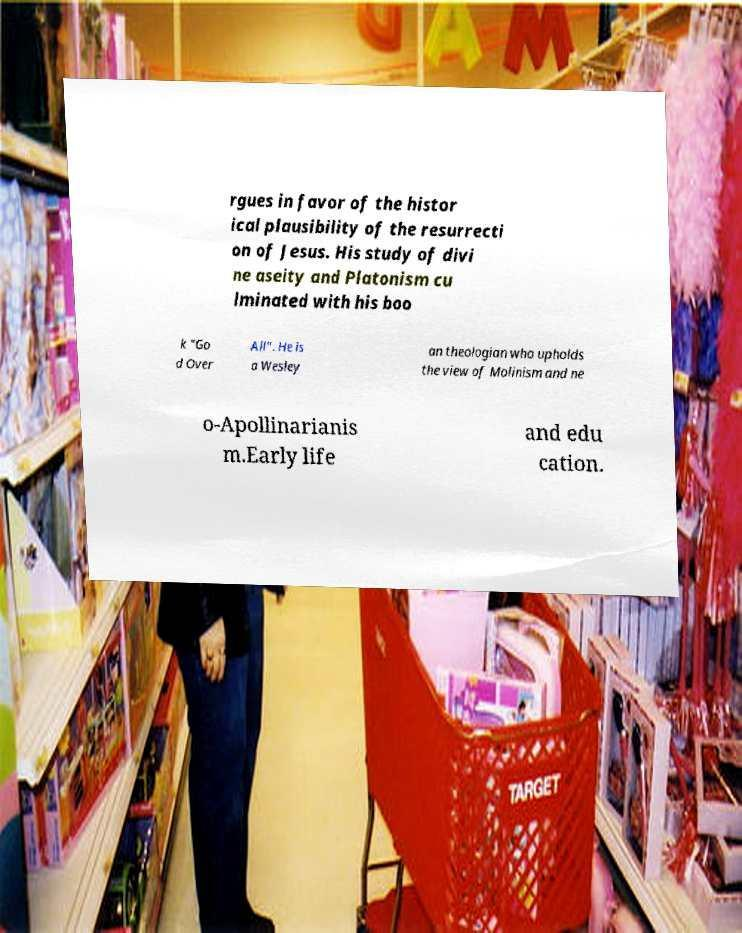Could you extract and type out the text from this image? rgues in favor of the histor ical plausibility of the resurrecti on of Jesus. His study of divi ne aseity and Platonism cu lminated with his boo k "Go d Over All". He is a Wesley an theologian who upholds the view of Molinism and ne o-Apollinarianis m.Early life and edu cation. 